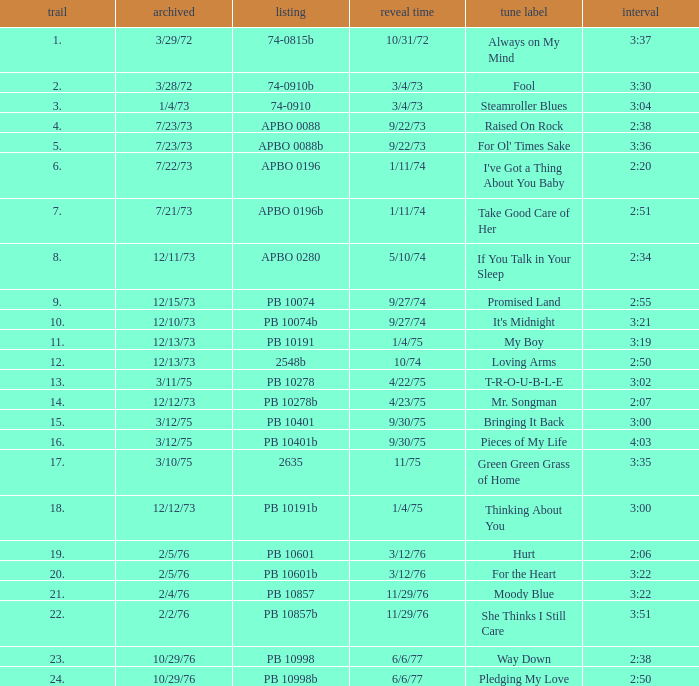Tell me the recorded for time of 2:50 and released date of 6/6/77 with track more than 20 10/29/76. 